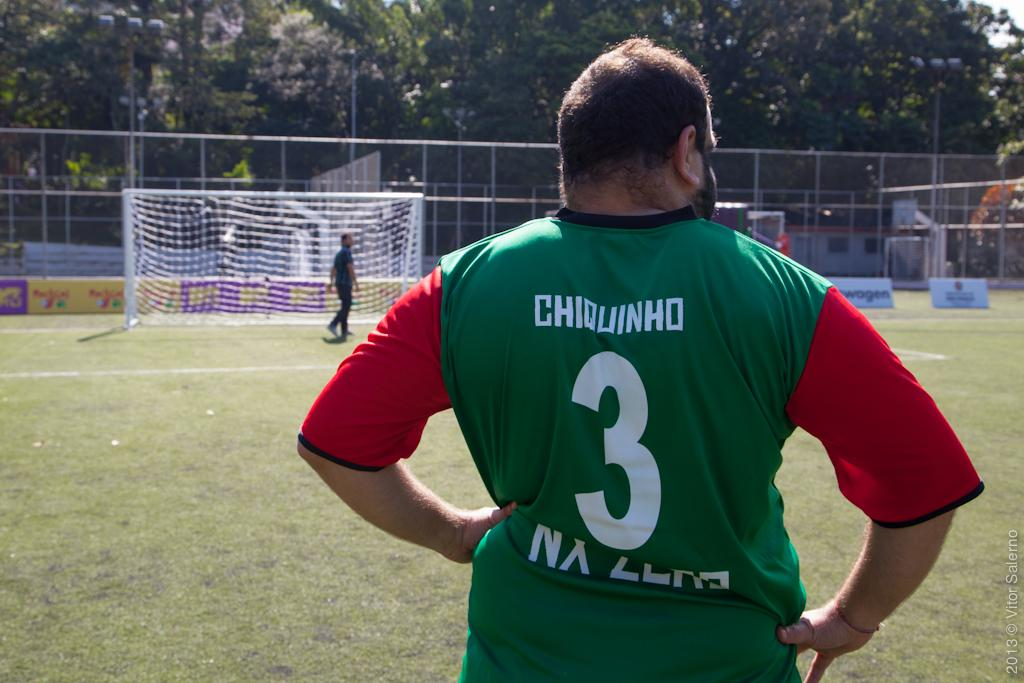<image>
Give a short and clear explanation of the subsequent image. A guy wearing a green shirt with the name Chiquinho on it. 